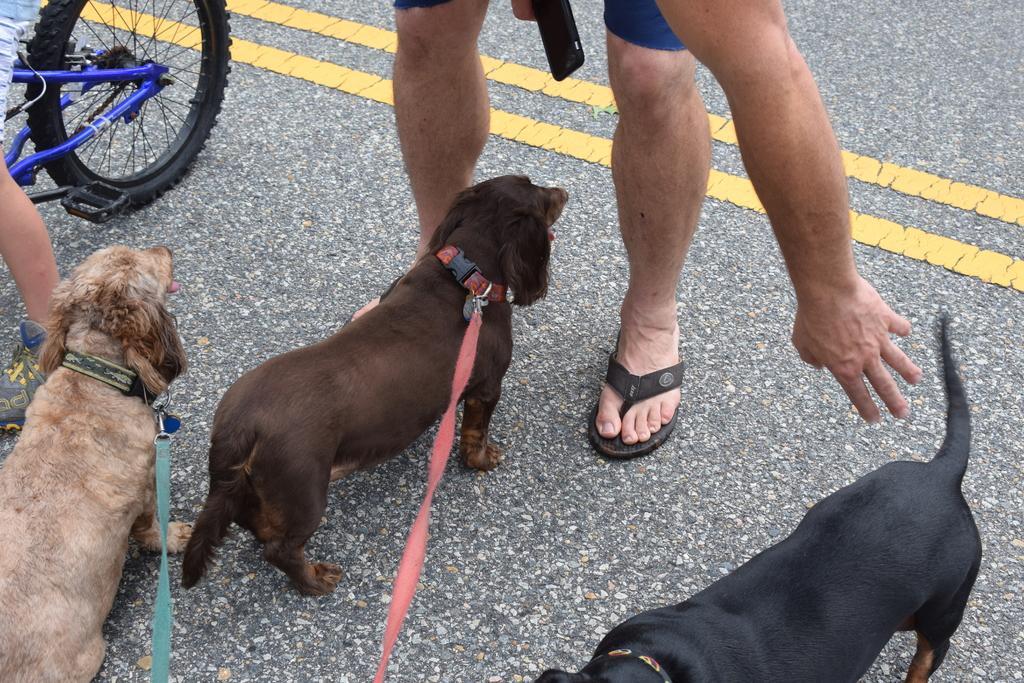Can you describe this image briefly? In this image I can see three dogs, they are in cream, brown, and black color. Background I can see a person standing and a bicycle on the road. 